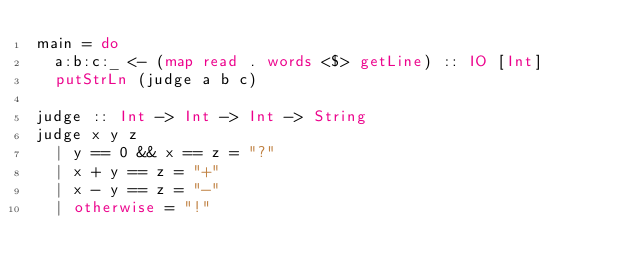<code> <loc_0><loc_0><loc_500><loc_500><_Haskell_>main = do
  a:b:c:_ <- (map read . words <$> getLine) :: IO [Int]
  putStrLn (judge a b c)

judge :: Int -> Int -> Int -> String
judge x y z
  | y == 0 && x == z = "?"
  | x + y == z = "+"
  | x - y == z = "-"
  | otherwise = "!"
</code> 